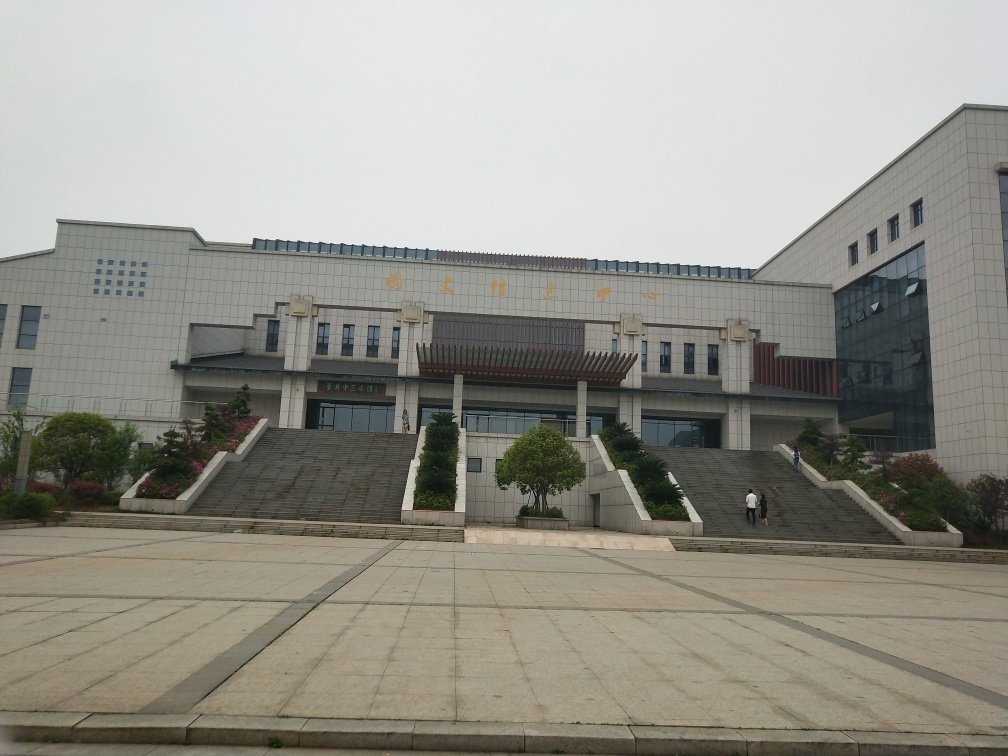Could you tell me more about the building's purpose based on its design and signage? Based on the prominent design and formal appearance, along with the characters on the facade that typically denote importance in an East Asian context, the building likely serves a significant civic or educational purpose. 